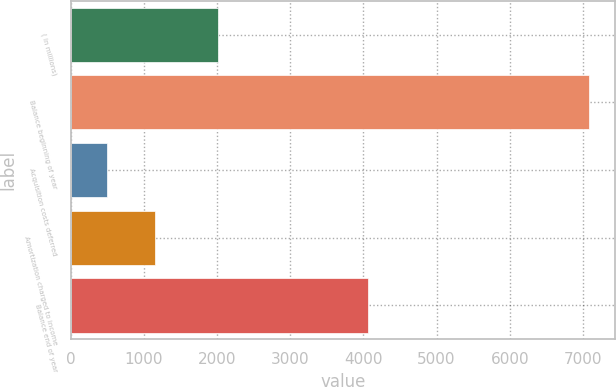Convert chart to OTSL. <chart><loc_0><loc_0><loc_500><loc_500><bar_chart><fcel>( in millions)<fcel>Balance beginning of year<fcel>Acquisition costs deferred<fcel>Amortization charged to income<fcel>Balance end of year<nl><fcel>2009<fcel>7089<fcel>495<fcel>1154.4<fcel>4060<nl></chart> 